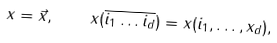<formula> <loc_0><loc_0><loc_500><loc_500>x = \vec { x } , \quad x ( \overline { i _ { 1 } \dots i _ { d } } ) = x ( i _ { 1 } , \dots , x _ { d } ) ,</formula> 